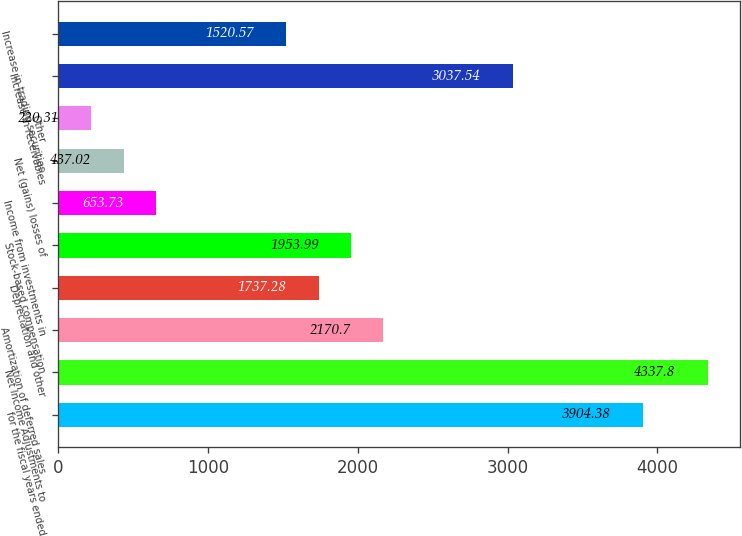<chart> <loc_0><loc_0><loc_500><loc_500><bar_chart><fcel>for the fiscal years ended<fcel>Net Income Adjustments to<fcel>Amortization of deferred sales<fcel>Depreciation and other<fcel>Stock-based compensation<fcel>Income from investments in<fcel>Net (gains) losses of<fcel>Other<fcel>Increase in receivables<fcel>Increase in trading securities<nl><fcel>3904.38<fcel>4337.8<fcel>2170.7<fcel>1737.28<fcel>1953.99<fcel>653.73<fcel>437.02<fcel>220.31<fcel>3037.54<fcel>1520.57<nl></chart> 